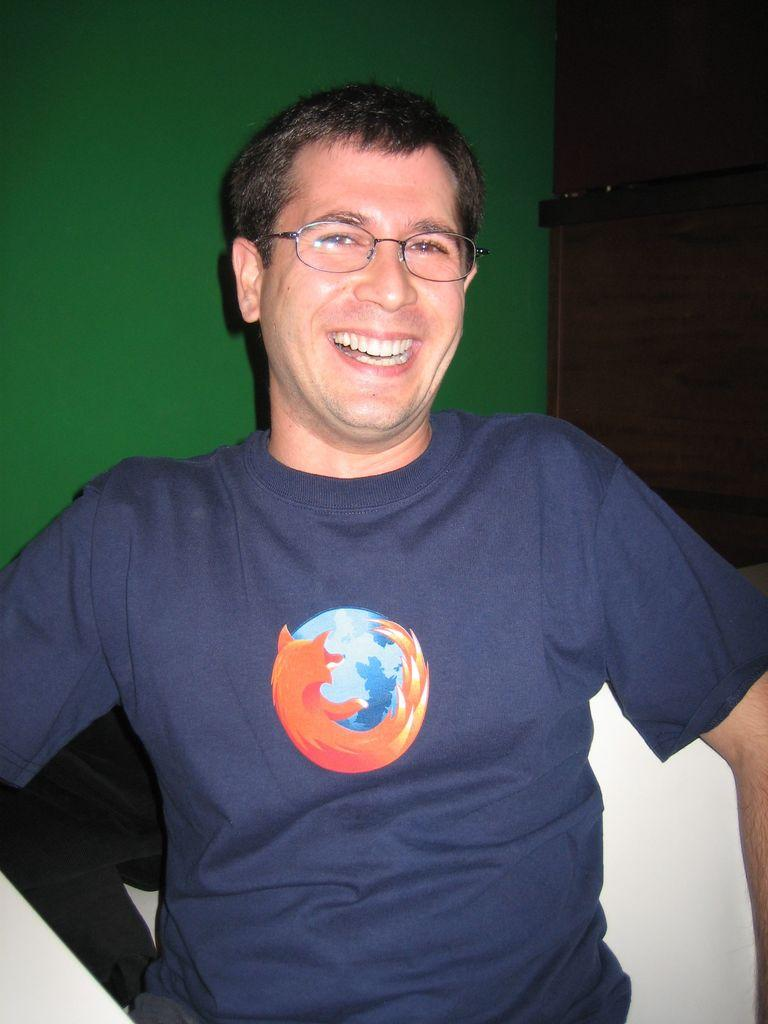What can be observed about the person in the image? The person in the image is smiling and wearing spectacles. Can you describe the person's facial expression? The person is smiling in the image. What is present in the background of the image? There is a cupboard in the background of the image, and the wall is green. What type of branch can be seen in the person's hand in the image? There is no branch present in the image, nor is there any indication that the person is holding anything in their hand. 